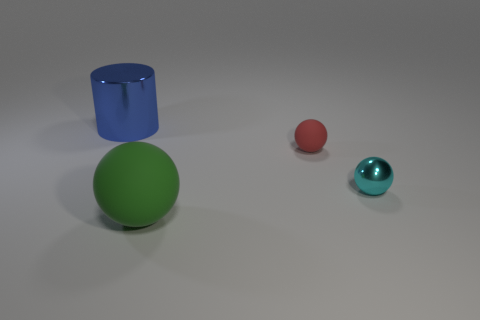Subtract all big matte balls. How many balls are left? 2 Add 1 red spheres. How many objects exist? 5 Subtract all brown rubber blocks. Subtract all rubber spheres. How many objects are left? 2 Add 1 tiny balls. How many tiny balls are left? 3 Add 2 gray metal spheres. How many gray metal spheres exist? 2 Subtract 0 brown cylinders. How many objects are left? 4 Subtract all balls. How many objects are left? 1 Subtract all purple balls. Subtract all cyan blocks. How many balls are left? 3 